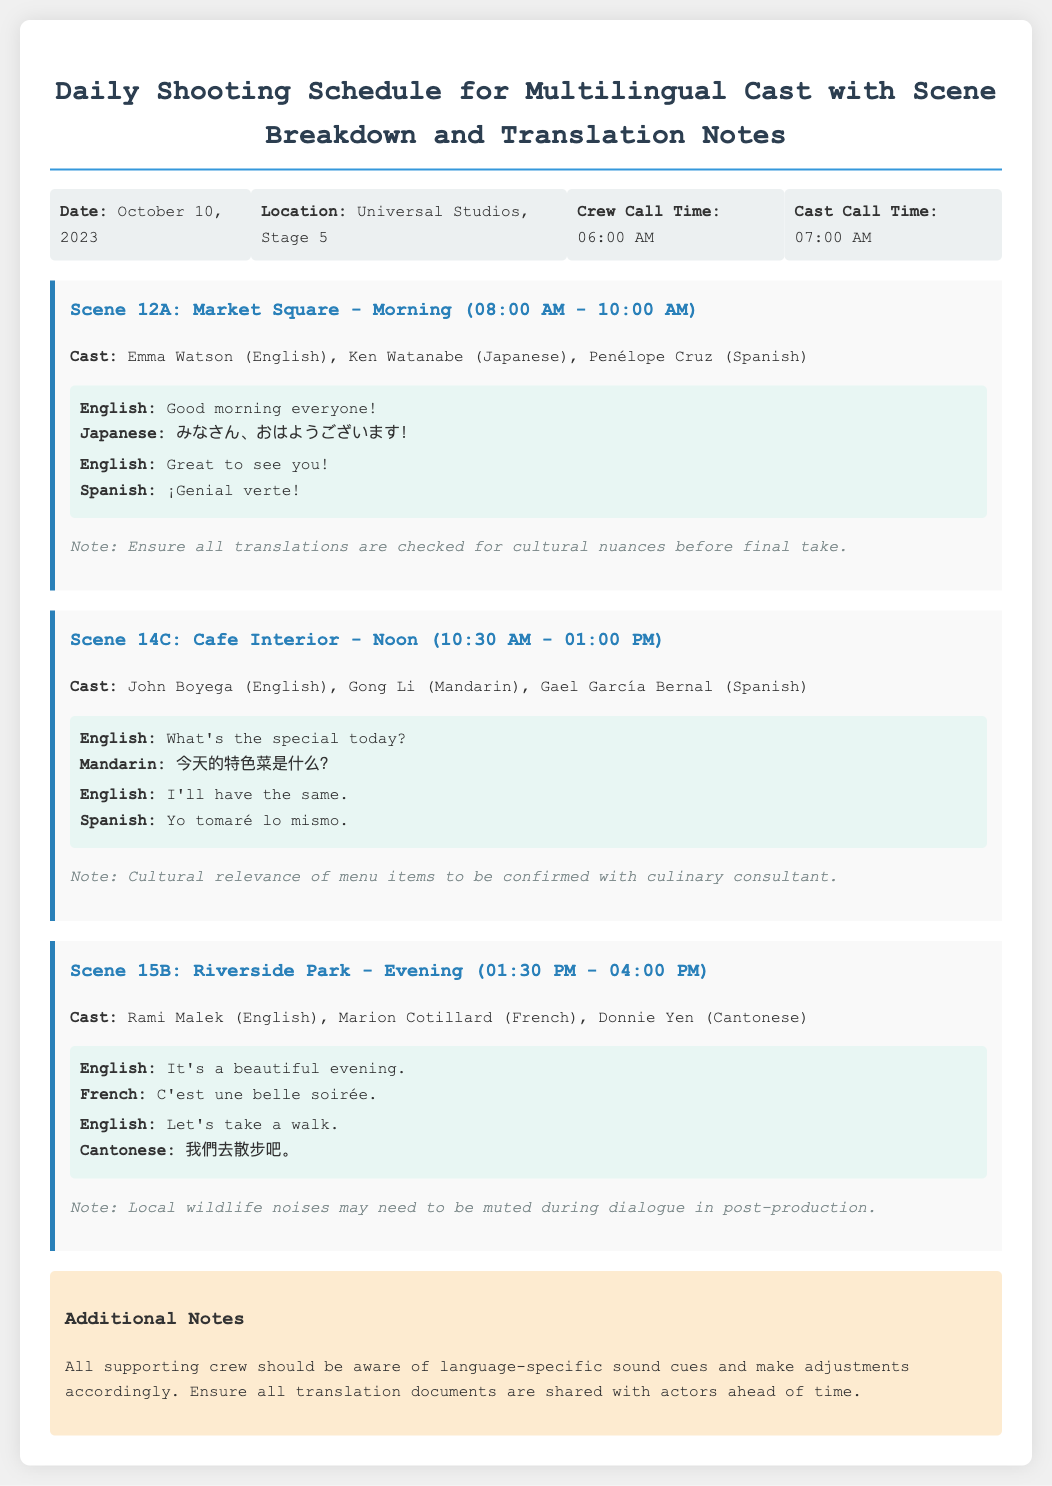What is the date of the shooting schedule? The document states that the shooting schedule is for October 10, 2023.
Answer: October 10, 2023 What is the crew call time? The crew call time is specified as 06:00 AM in the document.
Answer: 06:00 AM Who is in the cast for Scene 12A? The cast listed for Scene 12A includes Emma Watson, Ken Watanabe, and Penélope Cruz.
Answer: Emma Watson, Ken Watanabe, Penélope Cruz What is the translation for "Good morning everyone!" in Japanese? The document provides the Japanese translation as みなさん、おはようございます！.
Answer: みなさん、おはようございます！ What is the location of the filming? The filming location is given as Universal Studios, Stage 5.
Answer: Universal Studios, Stage 5 In which scene is the phrase "It's a beautiful evening." used? This phrase is found in Scene 15B as indicated in the document.
Answer: Scene 15B What is an additional note regarding supporting crew? The document notes that all supporting crew should be aware of language-specific sound cues.
Answer: Language-specific sound cues What time does Scene 14C take place? The time for Scene 14C is specified as 10:30 AM - 01:00 PM.
Answer: 10:30 AM - 01:00 PM What language is spoken by Gong Li in Scene 14C? The document states that Gong Li speaks Mandarin in Scene 14C.
Answer: Mandarin 